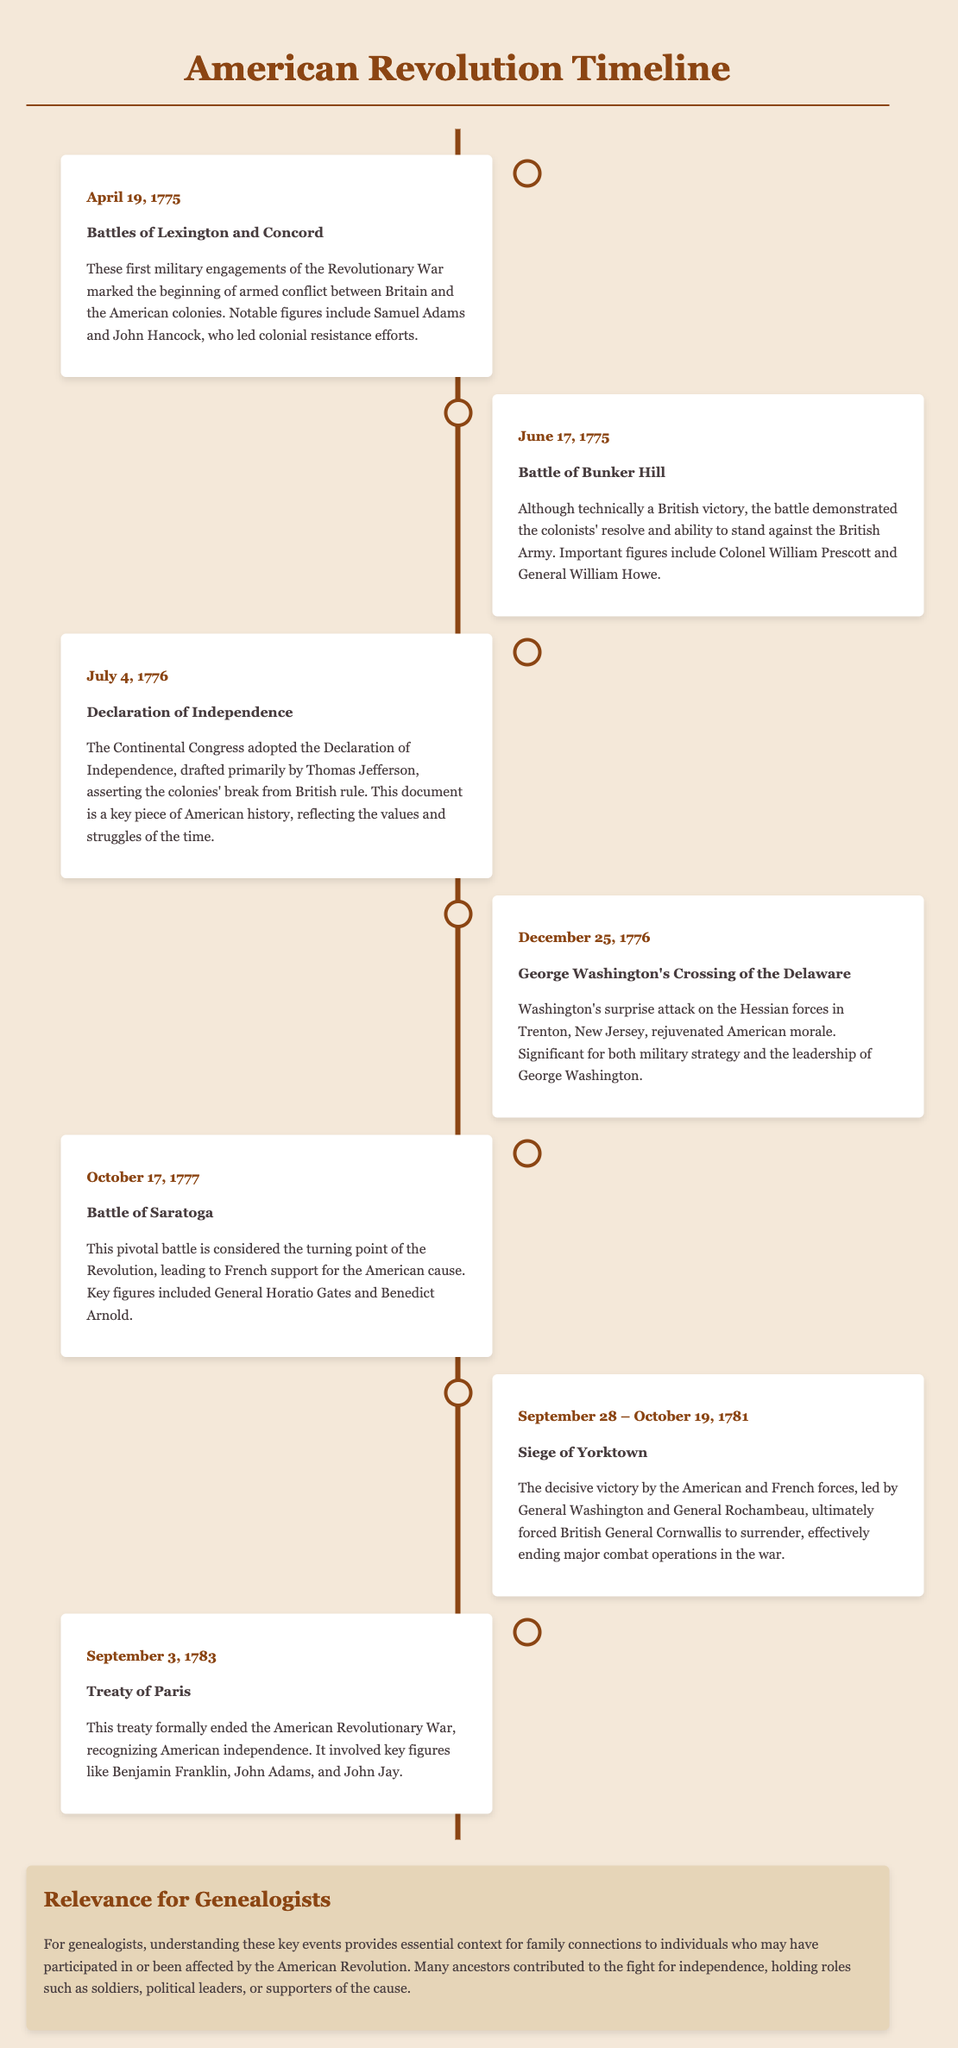What event marks the beginning of the American Revolution? The event that marks the beginning of the American Revolution is the Battles of Lexington and Concord, which occurred on April 19, 1775.
Answer: Battles of Lexington and Concord Who led the colonial resistance efforts during the initial conflict? Notable figures who led the colonial resistance efforts include Samuel Adams and John Hancock.
Answer: Samuel Adams and John Hancock What date was the Declaration of Independence adopted? The Declaration of Independence was adopted by the Continental Congress on July 4, 1776.
Answer: July 4, 1776 Which battle is considered a turning point of the Revolution? The Battle of Saratoga is considered the turning point of the Revolution, occurring on October 17, 1777.
Answer: Battle of Saratoga Who crossed the Delaware River on December 25, 1776? George Washington crossed the Delaware River on December 25, 1776.
Answer: George Washington Which two generals led the forces at the Siege of Yorktown? The two generals who led the forces at the Siege of Yorktown were General Washington and General Rochambeau.
Answer: General Washington and General Rochambeau What treaty formally ended the American Revolutionary War? The treaty that formally ended the American Revolutionary War is the Treaty of Paris, signed on September 3, 1783.
Answer: Treaty of Paris What significant outcome resulted from the Treaty of Paris? The significant outcome of the Treaty of Paris was the recognition of American independence.
Answer: Recognition of American independence How does this timeline benefit genealogists? The timeline provides essential context for family connections to individuals affected by the American Revolution.
Answer: Context for family connections 